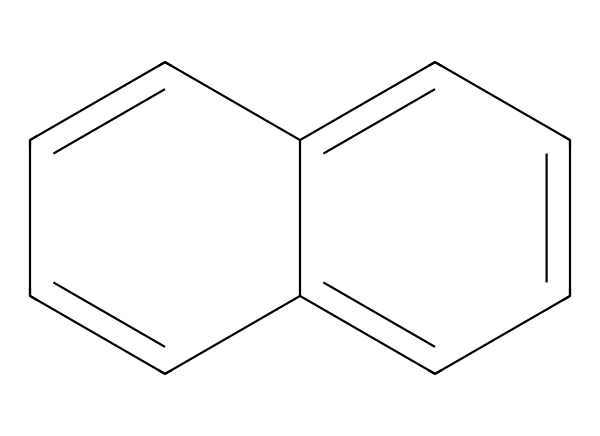What is the total number of carbon atoms in this structure? By examining the SMILES representation, we identify the rings and bonding which indicate the overall structure. Each 'C' corresponds to a carbon atom, and we can count them directly from the structure, revealing a total of 12 carbon atoms.
Answer: 12 How many double bonds are present in this chemical? In the SMILES representation, double bonds are indicated by the '=' symbol. By scanning the structure, we observe there are 6 double bonds that connect various carbon atoms within the rings.
Answer: 6 What type of material is represented by this molecular composition? The presence of a hexagonal carbon network indicates that this structure closely resembles that of carbon nanotubes, which are known to be nanomaterials used for lightweight and durable applications.
Answer: carbon nanotubes Does this chemical have aromatic properties? The presence of alternating double bonds in a cyclic structure suggests the chemical is aromatic. Aromatic compounds are typically stabilized by resonance, which is seen here due to their structure, verifying its aromatic characteristics.
Answer: yes What is the significance of using carbon nanotubes in volleyball nets? Carbon nanotubes provide significant strength-to-weight ratio and flexibility, leading to increased durability and performance in lightweight applications such as volleyball nets.
Answer: strength-to-weight ratio 